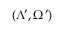<formula> <loc_0><loc_0><loc_500><loc_500>( \Lambda ^ { \prime } , \Omega ^ { \prime } )</formula> 